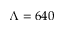Convert formula to latex. <formula><loc_0><loc_0><loc_500><loc_500>\Lambda = 6 4 0</formula> 